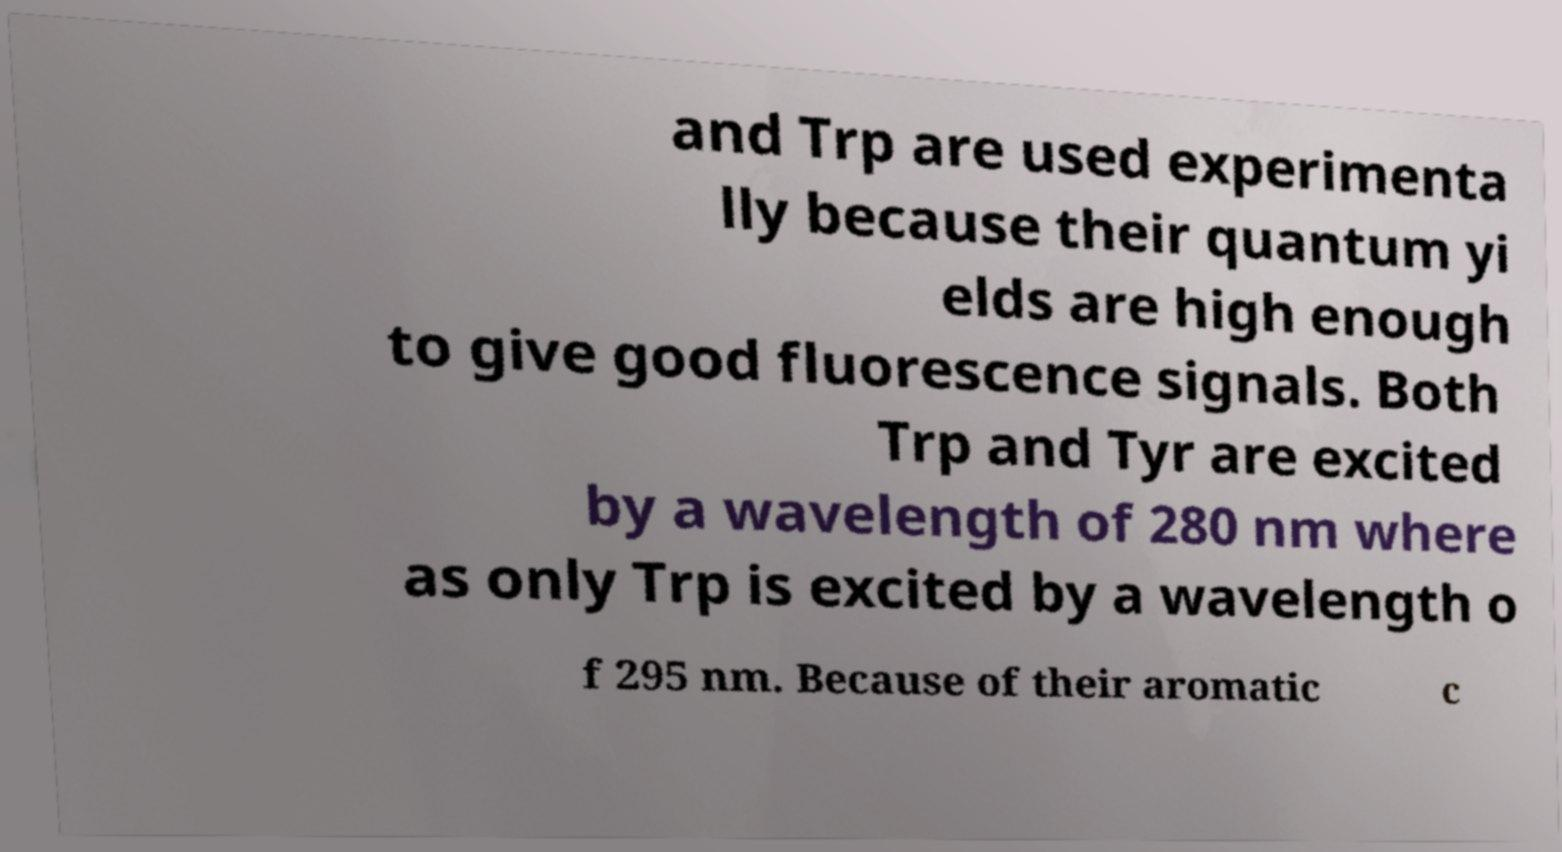Could you assist in decoding the text presented in this image and type it out clearly? and Trp are used experimenta lly because their quantum yi elds are high enough to give good fluorescence signals. Both Trp and Tyr are excited by a wavelength of 280 nm where as only Trp is excited by a wavelength o f 295 nm. Because of their aromatic c 